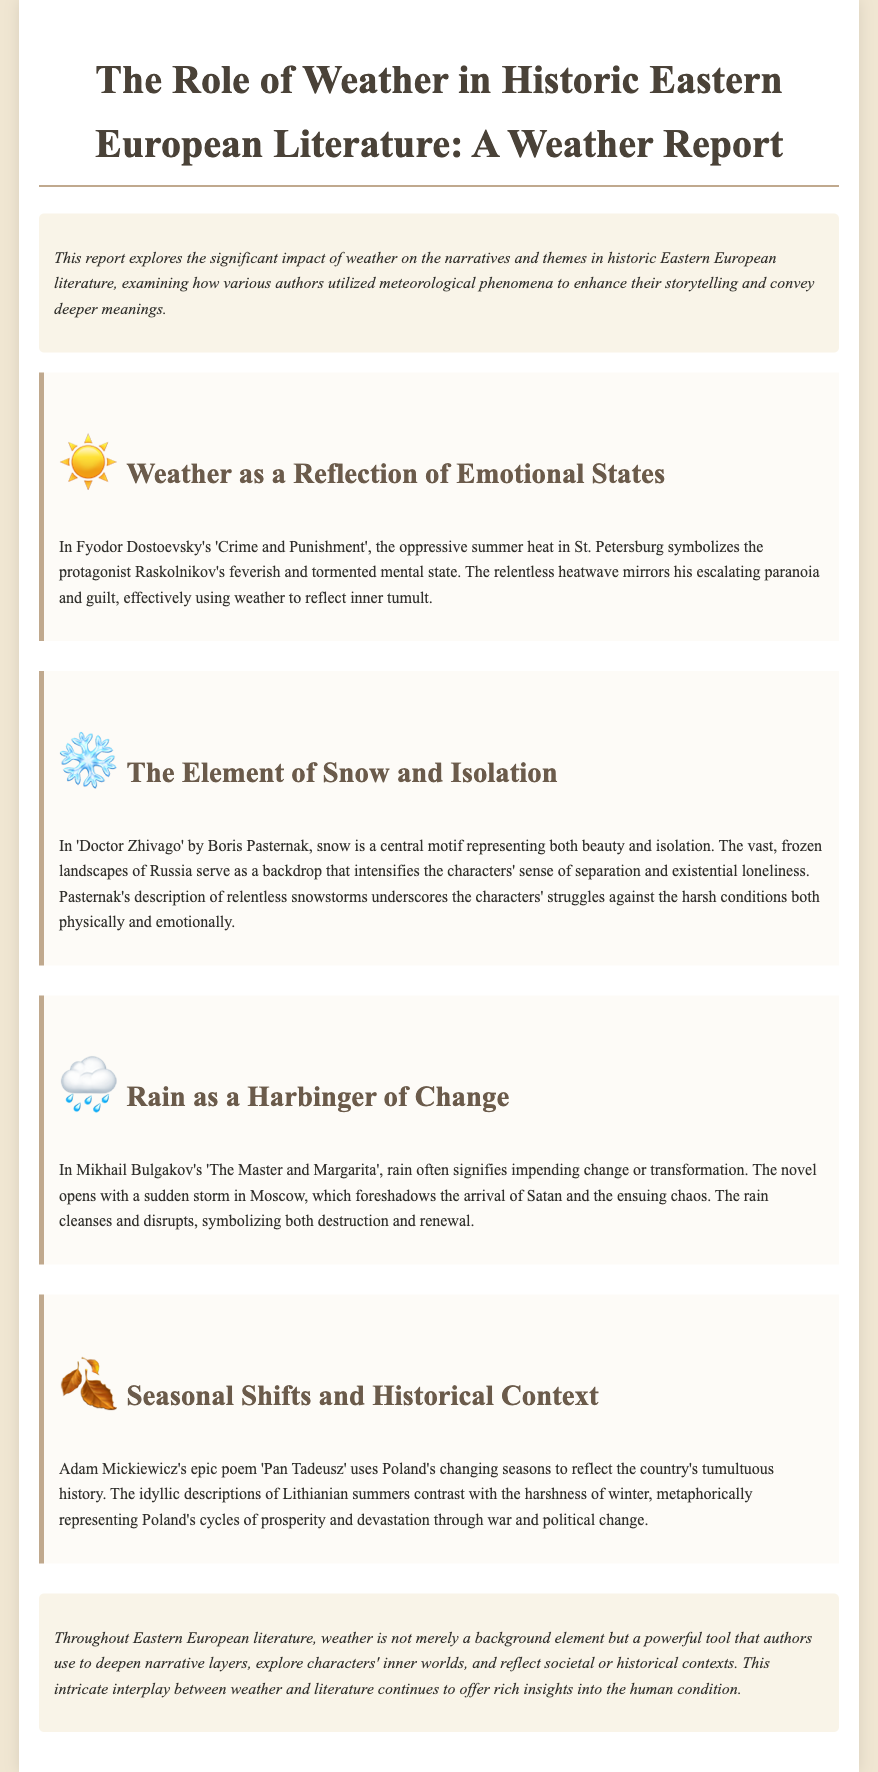What is the title of the report? The title of the report is stated prominently at the beginning of the document.
Answer: The Role of Weather in Historic Eastern European Literature: A Weather Report Who is the author of 'Doctor Zhivago'? The document mentions Boris Pasternak as the author of 'Doctor Zhivago'.
Answer: Boris Pasternak What weather phenomenon symbolizes Raskolnikov's mental state? The report discusses how oppressive summer heat symbolizes Raskolnikov's mental state in 'Crime and Punishment'.
Answer: Summer heat Which author uses seasonal shifts to reflect Poland's history? The section mentions Adam Mickiewicz as the author who uses changing seasons metaphorically.
Answer: Adam Mickiewicz What does rain symbolize in 'The Master and Margarita'? The document indicates that rain signifies impending change or transformation in Mikhail Bulgakov's work.
Answer: Change How is snow described in 'Doctor Zhivago'? The report describes snow as a central motif that represents both beauty and isolation.
Answer: Beauty and isolation What is the emotional state reflected by the weather in Dostoevsky's work? It reflects inner tumult through oppressive summer heat symbolizing Raskolnikov's feelings.
Answer: Inner tumult What unique perspective does the report provide about weather in literature? The document highlights that weather is a powerful tool that deepens narrative layers.
Answer: A powerful tool 